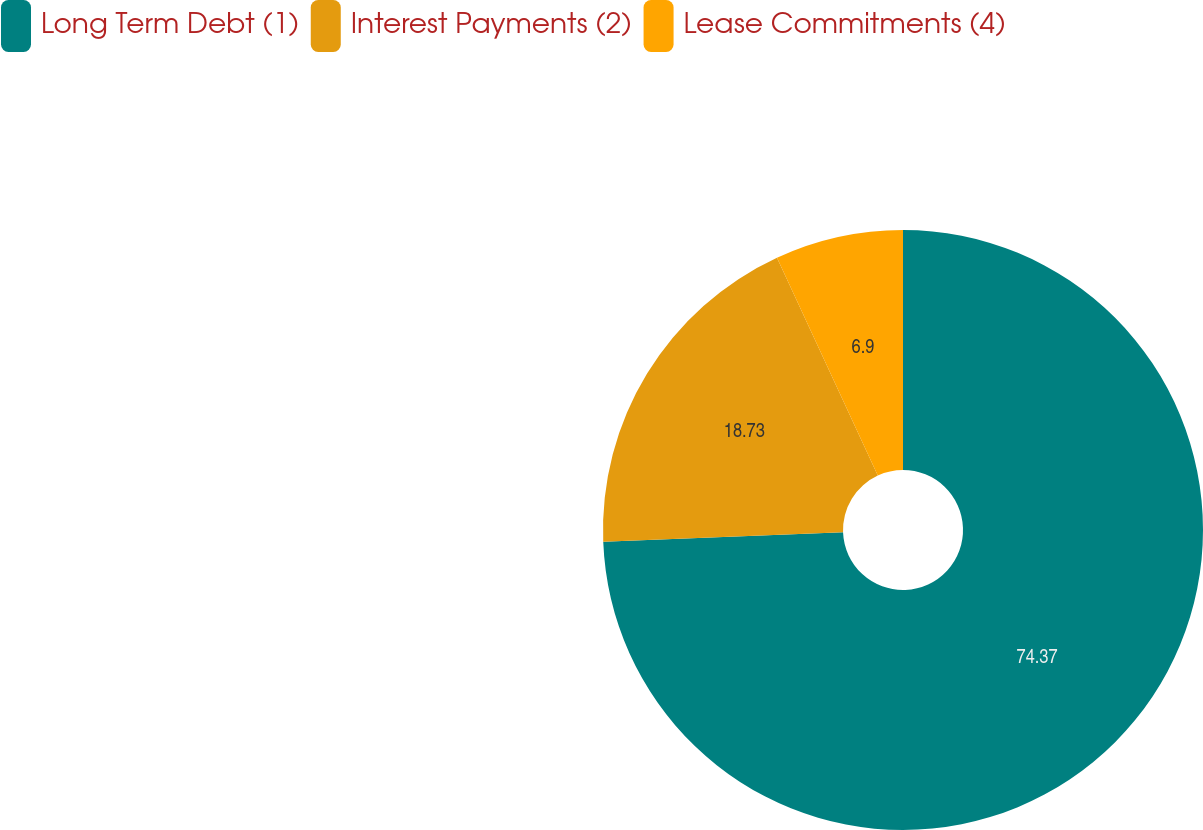Convert chart. <chart><loc_0><loc_0><loc_500><loc_500><pie_chart><fcel>Long Term Debt (1)<fcel>Interest Payments (2)<fcel>Lease Commitments (4)<nl><fcel>74.38%<fcel>18.73%<fcel>6.9%<nl></chart> 